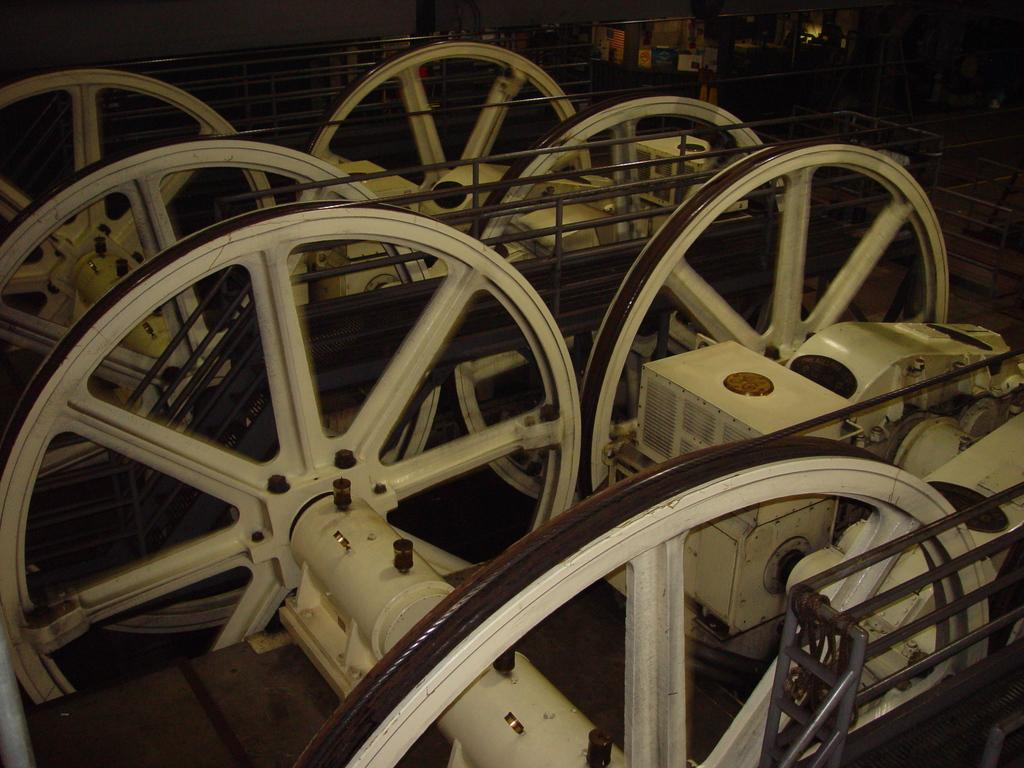What can be seen in the image? There are machines in the image. Can you describe the machines in more detail? Unfortunately, the provided facts do not offer any additional details about the machines. Are there any other objects or elements in the image besides the machines? The given facts do not mention any other objects or elements in the image. What type of scarf is being knitted by the machines in the image? There is no mention of scarves or yarn in the provided facts, and the image does not show any knitting activity. 